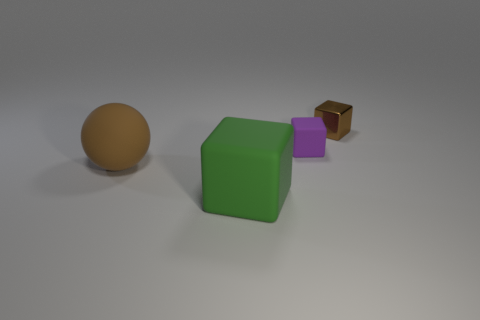Does the green thing have the same shape as the large thing that is to the left of the big block?
Offer a terse response. No. Are there any small purple matte cubes in front of the purple rubber cube?
Your answer should be compact. No. What is the material of the small object that is the same color as the ball?
Offer a very short reply. Metal. Does the brown metallic cube have the same size as the brown thing in front of the purple rubber thing?
Your answer should be very brief. No. Is there a small object that has the same color as the small rubber block?
Make the answer very short. No. Are there any other small purple things that have the same shape as the tiny purple matte object?
Offer a very short reply. No. What shape is the object that is both on the right side of the green object and on the left side of the brown block?
Ensure brevity in your answer.  Cube. What number of large green blocks have the same material as the large brown sphere?
Your answer should be very brief. 1. Is the number of matte objects behind the green rubber thing less than the number of purple rubber objects?
Make the answer very short. No. There is a brown object that is behind the big brown rubber thing; are there any big matte objects right of it?
Make the answer very short. No. 